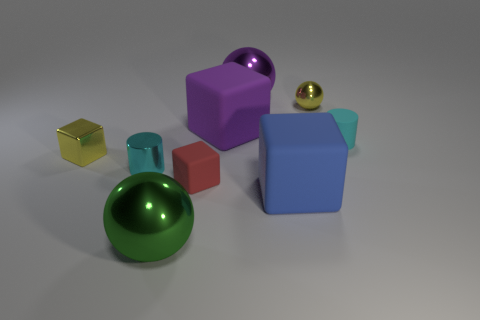Subtract all large green metallic balls. How many balls are left? 2 Subtract all cylinders. How many objects are left? 7 Subtract all purple spheres. How many spheres are left? 2 Subtract all red cylinders. Subtract all tiny yellow shiny things. How many objects are left? 7 Add 5 tiny metallic things. How many tiny metallic things are left? 8 Add 3 purple metallic things. How many purple metallic things exist? 4 Subtract 0 brown cylinders. How many objects are left? 9 Subtract all yellow cylinders. Subtract all cyan blocks. How many cylinders are left? 2 Subtract all cyan cylinders. How many purple balls are left? 1 